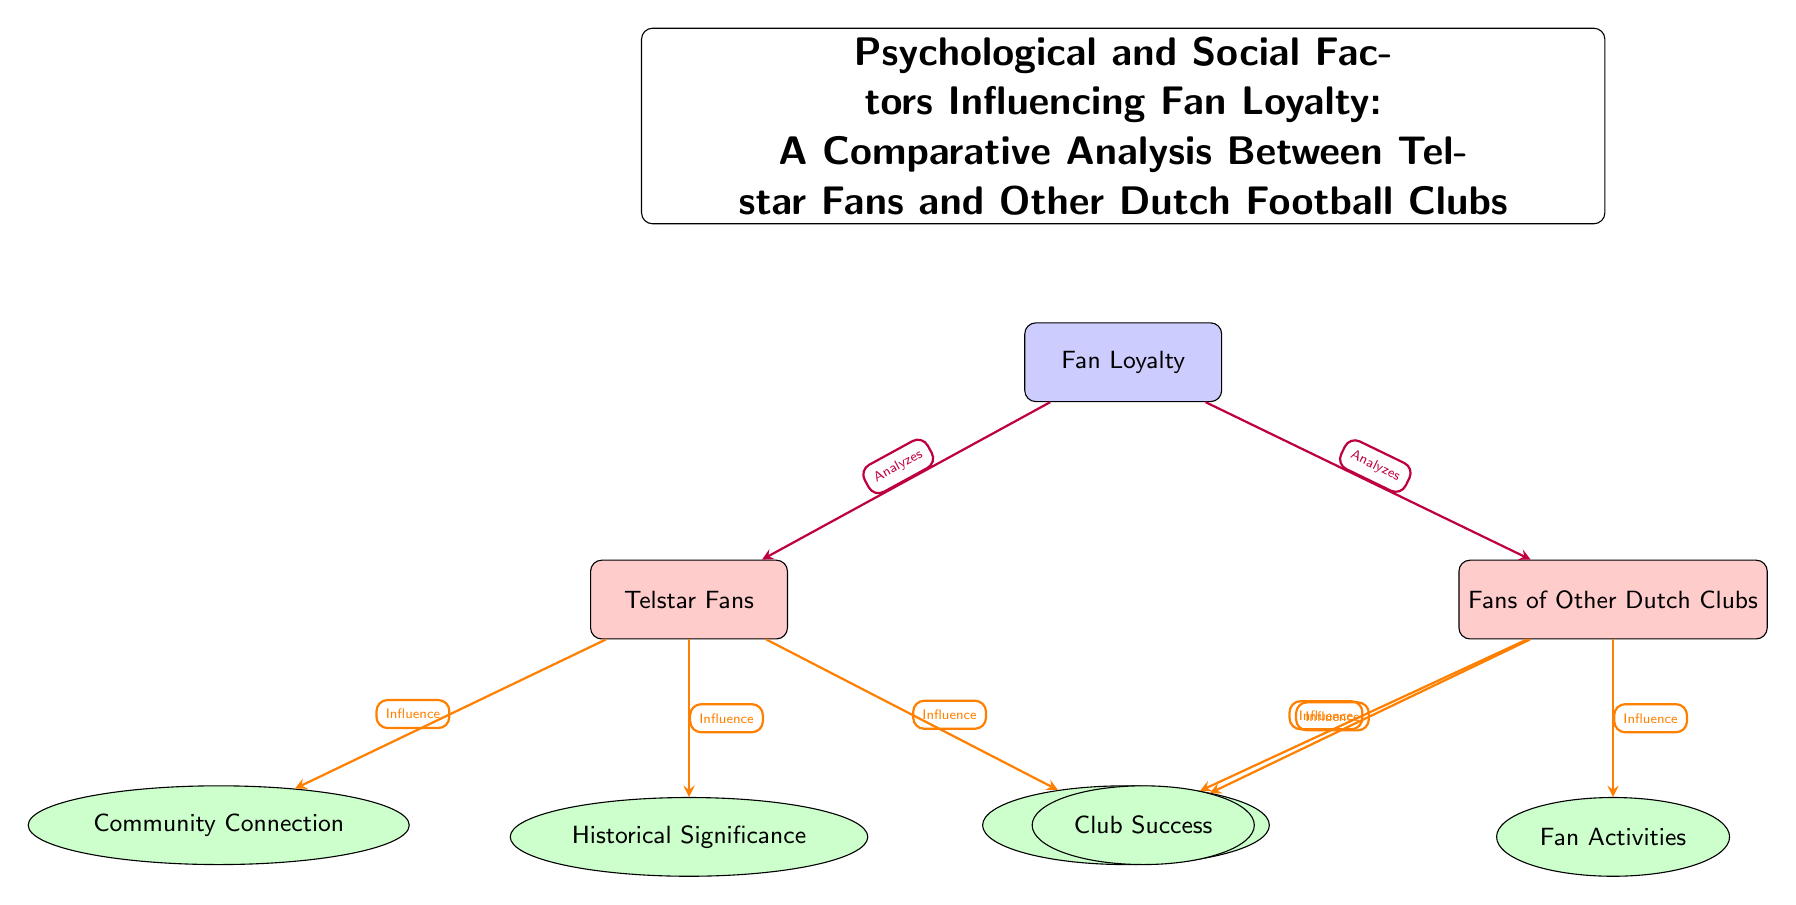What is the main focus of the diagram? The main focus is represented by the node labeled "Fan Loyalty" at the center of the diagram, which indicates the primary subject of the analysis.
Answer: Fan Loyalty How many factors influence Telstar fans? There are three factors listed that influence Telstar fans: Community Connection, Historical Significance, and Game Experience. This is determined by counting the factors directly connected to the Telstar Fans node.
Answer: 3 Which factor affects fans of other Dutch clubs but does not affect Telstar fans? The factor "Club Success" is unique to the fans of other Dutch clubs and is not connected to the Telstar fans node. This can be seen by looking at the factors listed under each fan group.
Answer: Club Success Which two factors influence both Telstar fans and other club fans? The factor "Game Experience" is connected to both Telstar fans and fans of other Dutch clubs, indicating that it influences both groups.
Answer: Game Experience What relationship does "Community Connection" have with Telstar fans? "Community Connection" has a direct influence on Telstar fans, as indicated by the arrow leading from the Telstar fans node to the Community Connection node, showing a one-way influence.
Answer: Influence What is the group of fans compared in this analysis? The groups compared are "Telstar Fans" and "Fans of Other Dutch Clubs," as indicated by their respective labels to the left and right of the central node.
Answer: Telstar Fans and Fans of Other Dutch Clubs What type of diagram is this? This diagram is a "Social Science Diagram," focusing on psychological and social factors influencing fan loyalty and comparing different groups of fans.
Answer: Social Science Diagram Which node has the fewest connections? The node "Historical Significance" has no outgoing connections, only an incoming connection from the Telstar fans, indicating it is influenced but does not influence any other node.
Answer: Historical Significance 